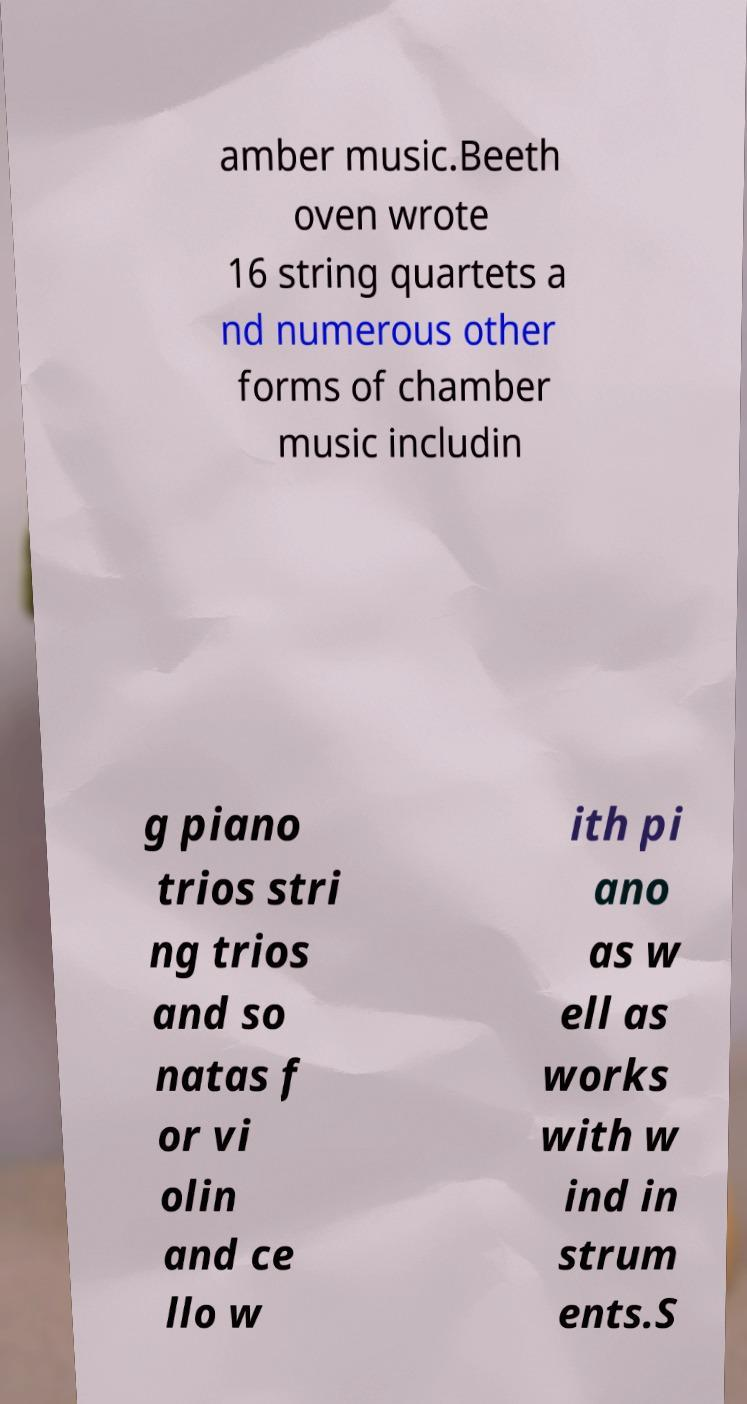Please read and relay the text visible in this image. What does it say? amber music.Beeth oven wrote 16 string quartets a nd numerous other forms of chamber music includin g piano trios stri ng trios and so natas f or vi olin and ce llo w ith pi ano as w ell as works with w ind in strum ents.S 